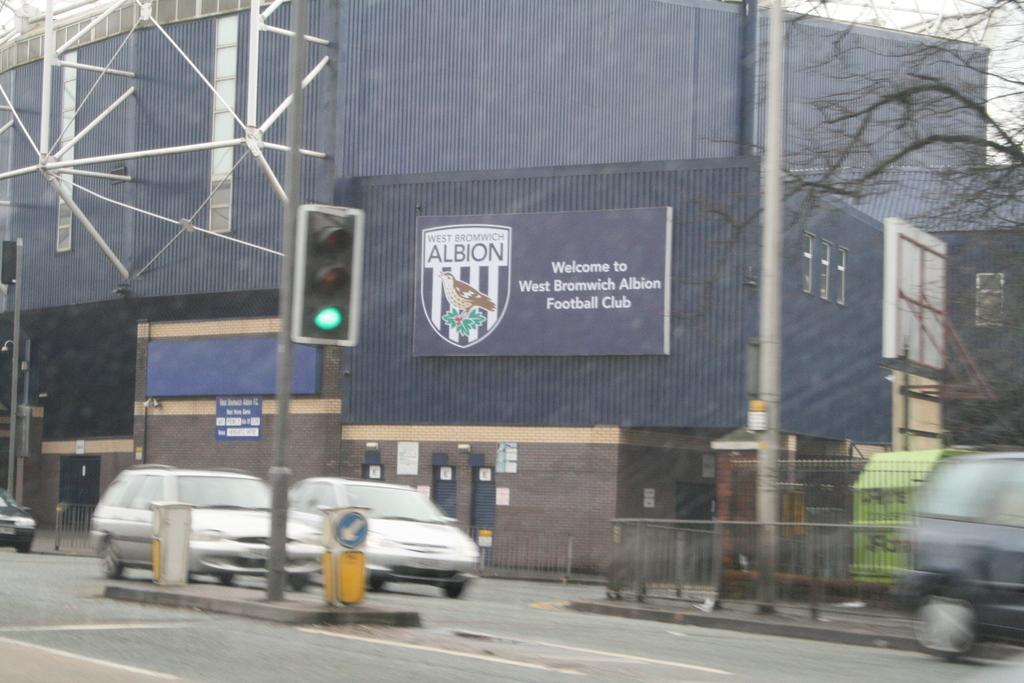What is happening on the road in the image? There are vehicles moving on the road in the image. What can be seen on the poles in the image? There are poles with lights in the image. What type of vegetation is present at the right side in the image? There is a tree at the right side in the image. What type of structure is visible in the image? There is a building in the image. What type of linen is draped over the coach in the image? There is no coach or linen present in the image. How many cups are visible on the table in the image? There is no table or cup present in the image. 